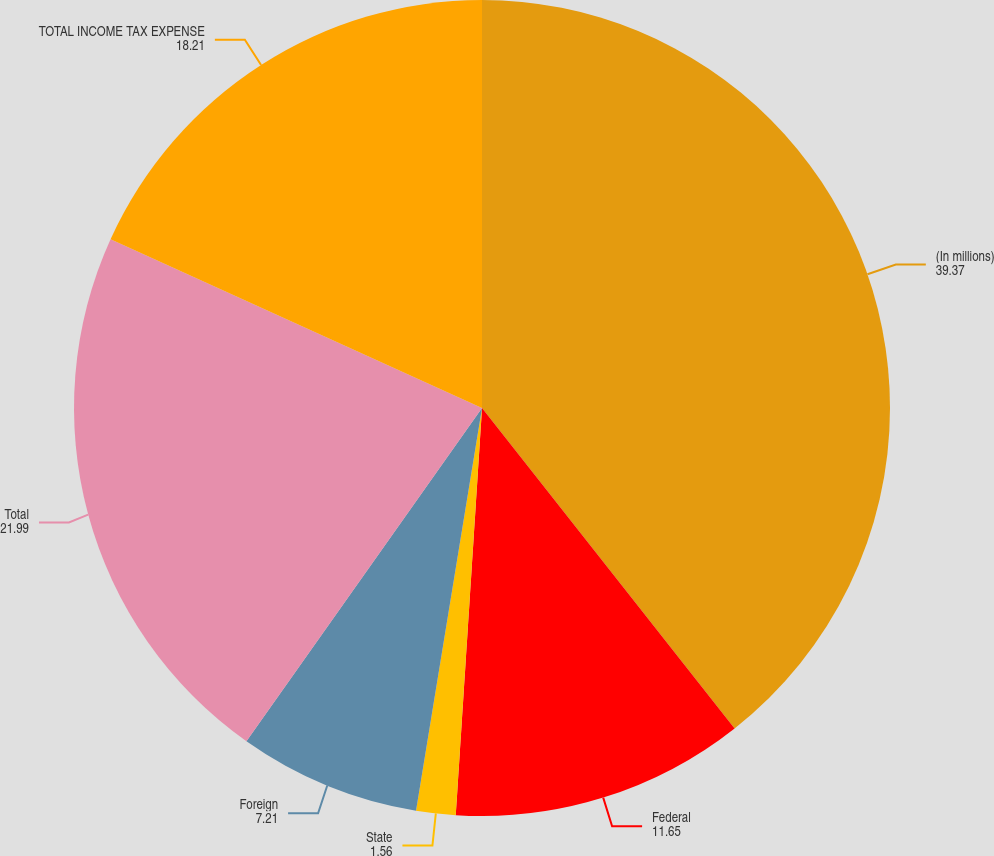Convert chart to OTSL. <chart><loc_0><loc_0><loc_500><loc_500><pie_chart><fcel>(In millions)<fcel>Federal<fcel>State<fcel>Foreign<fcel>Total<fcel>TOTAL INCOME TAX EXPENSE<nl><fcel>39.37%<fcel>11.65%<fcel>1.56%<fcel>7.21%<fcel>21.99%<fcel>18.21%<nl></chart> 